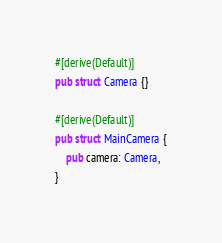<code> <loc_0><loc_0><loc_500><loc_500><_Rust_>#[derive(Default)]
pub struct Camera {}

#[derive(Default)]
pub struct MainCamera {
    pub camera: Camera,
}
</code> 